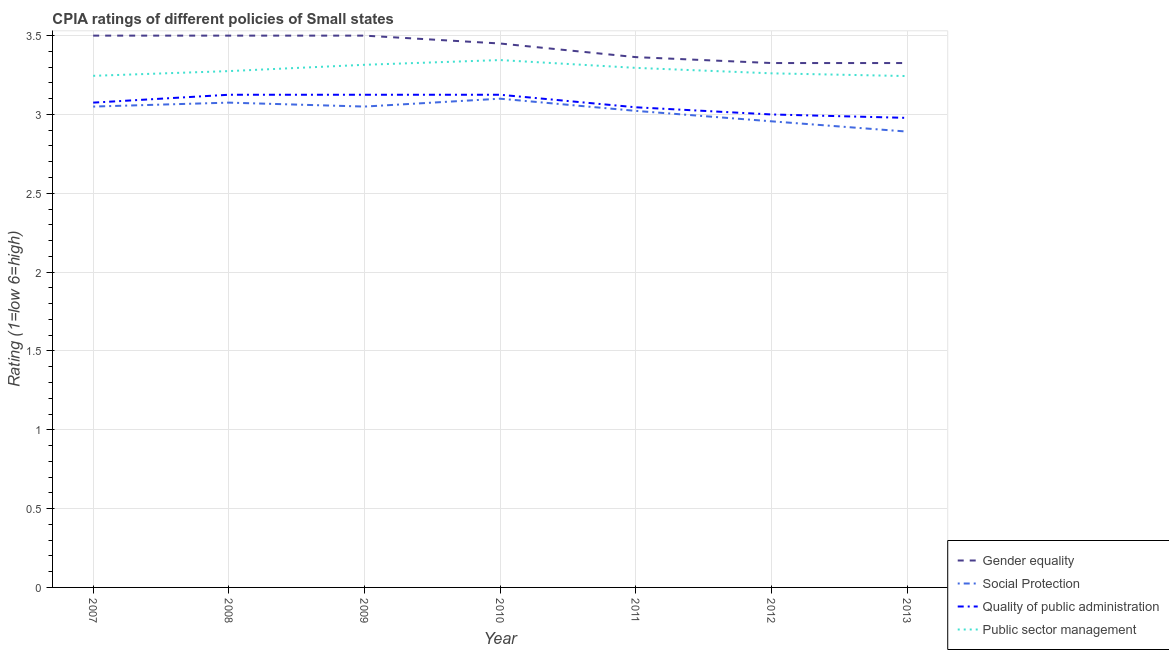What is the cpia rating of gender equality in 2013?
Your answer should be very brief. 3.33. Across all years, what is the maximum cpia rating of public sector management?
Keep it short and to the point. 3.35. Across all years, what is the minimum cpia rating of public sector management?
Your answer should be very brief. 3.24. In which year was the cpia rating of quality of public administration maximum?
Give a very brief answer. 2008. In which year was the cpia rating of gender equality minimum?
Offer a very short reply. 2012. What is the total cpia rating of public sector management in the graph?
Your answer should be very brief. 22.98. What is the difference between the cpia rating of gender equality in 2007 and that in 2010?
Make the answer very short. 0.05. What is the difference between the cpia rating of gender equality in 2009 and the cpia rating of social protection in 2012?
Offer a terse response. 0.54. What is the average cpia rating of social protection per year?
Ensure brevity in your answer.  3.02. In the year 2013, what is the difference between the cpia rating of gender equality and cpia rating of public sector management?
Offer a terse response. 0.08. Is the cpia rating of public sector management in 2007 less than that in 2009?
Your answer should be very brief. Yes. What is the difference between the highest and the second highest cpia rating of social protection?
Your response must be concise. 0.02. What is the difference between the highest and the lowest cpia rating of public sector management?
Make the answer very short. 0.1. Is it the case that in every year, the sum of the cpia rating of gender equality and cpia rating of social protection is greater than the cpia rating of quality of public administration?
Keep it short and to the point. Yes. Is the cpia rating of quality of public administration strictly less than the cpia rating of social protection over the years?
Give a very brief answer. No. What is the difference between two consecutive major ticks on the Y-axis?
Make the answer very short. 0.5. Are the values on the major ticks of Y-axis written in scientific E-notation?
Ensure brevity in your answer.  No. Does the graph contain any zero values?
Keep it short and to the point. No. Where does the legend appear in the graph?
Offer a very short reply. Bottom right. How many legend labels are there?
Your answer should be very brief. 4. What is the title of the graph?
Your answer should be very brief. CPIA ratings of different policies of Small states. What is the Rating (1=low 6=high) of Gender equality in 2007?
Give a very brief answer. 3.5. What is the Rating (1=low 6=high) in Social Protection in 2007?
Offer a terse response. 3.05. What is the Rating (1=low 6=high) of Quality of public administration in 2007?
Your response must be concise. 3.08. What is the Rating (1=low 6=high) of Public sector management in 2007?
Make the answer very short. 3.25. What is the Rating (1=low 6=high) of Social Protection in 2008?
Ensure brevity in your answer.  3.08. What is the Rating (1=low 6=high) of Quality of public administration in 2008?
Your answer should be very brief. 3.12. What is the Rating (1=low 6=high) of Public sector management in 2008?
Offer a very short reply. 3.27. What is the Rating (1=low 6=high) in Social Protection in 2009?
Ensure brevity in your answer.  3.05. What is the Rating (1=low 6=high) of Quality of public administration in 2009?
Offer a very short reply. 3.12. What is the Rating (1=low 6=high) of Public sector management in 2009?
Your response must be concise. 3.31. What is the Rating (1=low 6=high) in Gender equality in 2010?
Keep it short and to the point. 3.45. What is the Rating (1=low 6=high) of Quality of public administration in 2010?
Your answer should be very brief. 3.12. What is the Rating (1=low 6=high) in Public sector management in 2010?
Offer a terse response. 3.35. What is the Rating (1=low 6=high) of Gender equality in 2011?
Ensure brevity in your answer.  3.36. What is the Rating (1=low 6=high) in Social Protection in 2011?
Your answer should be compact. 3.02. What is the Rating (1=low 6=high) in Quality of public administration in 2011?
Give a very brief answer. 3.05. What is the Rating (1=low 6=high) in Public sector management in 2011?
Ensure brevity in your answer.  3.3. What is the Rating (1=low 6=high) in Gender equality in 2012?
Your answer should be compact. 3.33. What is the Rating (1=low 6=high) in Social Protection in 2012?
Your answer should be very brief. 2.96. What is the Rating (1=low 6=high) of Quality of public administration in 2012?
Your response must be concise. 3. What is the Rating (1=low 6=high) in Public sector management in 2012?
Provide a short and direct response. 3.26. What is the Rating (1=low 6=high) in Gender equality in 2013?
Provide a succinct answer. 3.33. What is the Rating (1=low 6=high) in Social Protection in 2013?
Keep it short and to the point. 2.89. What is the Rating (1=low 6=high) in Quality of public administration in 2013?
Keep it short and to the point. 2.98. What is the Rating (1=low 6=high) of Public sector management in 2013?
Offer a terse response. 3.24. Across all years, what is the maximum Rating (1=low 6=high) of Gender equality?
Your answer should be very brief. 3.5. Across all years, what is the maximum Rating (1=low 6=high) of Quality of public administration?
Keep it short and to the point. 3.12. Across all years, what is the maximum Rating (1=low 6=high) in Public sector management?
Keep it short and to the point. 3.35. Across all years, what is the minimum Rating (1=low 6=high) in Gender equality?
Ensure brevity in your answer.  3.33. Across all years, what is the minimum Rating (1=low 6=high) in Social Protection?
Provide a short and direct response. 2.89. Across all years, what is the minimum Rating (1=low 6=high) in Quality of public administration?
Keep it short and to the point. 2.98. Across all years, what is the minimum Rating (1=low 6=high) of Public sector management?
Your answer should be compact. 3.24. What is the total Rating (1=low 6=high) in Gender equality in the graph?
Your answer should be compact. 23.97. What is the total Rating (1=low 6=high) in Social Protection in the graph?
Make the answer very short. 21.15. What is the total Rating (1=low 6=high) in Quality of public administration in the graph?
Your response must be concise. 21.47. What is the total Rating (1=low 6=high) of Public sector management in the graph?
Provide a short and direct response. 22.98. What is the difference between the Rating (1=low 6=high) in Social Protection in 2007 and that in 2008?
Provide a succinct answer. -0.03. What is the difference between the Rating (1=low 6=high) in Public sector management in 2007 and that in 2008?
Make the answer very short. -0.03. What is the difference between the Rating (1=low 6=high) in Gender equality in 2007 and that in 2009?
Offer a terse response. 0. What is the difference between the Rating (1=low 6=high) in Quality of public administration in 2007 and that in 2009?
Provide a short and direct response. -0.05. What is the difference between the Rating (1=low 6=high) in Public sector management in 2007 and that in 2009?
Make the answer very short. -0.07. What is the difference between the Rating (1=low 6=high) in Social Protection in 2007 and that in 2010?
Ensure brevity in your answer.  -0.05. What is the difference between the Rating (1=low 6=high) of Public sector management in 2007 and that in 2010?
Provide a short and direct response. -0.1. What is the difference between the Rating (1=low 6=high) of Gender equality in 2007 and that in 2011?
Keep it short and to the point. 0.14. What is the difference between the Rating (1=low 6=high) in Social Protection in 2007 and that in 2011?
Offer a terse response. 0.03. What is the difference between the Rating (1=low 6=high) in Quality of public administration in 2007 and that in 2011?
Keep it short and to the point. 0.03. What is the difference between the Rating (1=low 6=high) of Public sector management in 2007 and that in 2011?
Offer a terse response. -0.05. What is the difference between the Rating (1=low 6=high) in Gender equality in 2007 and that in 2012?
Your response must be concise. 0.17. What is the difference between the Rating (1=low 6=high) of Social Protection in 2007 and that in 2012?
Keep it short and to the point. 0.09. What is the difference between the Rating (1=low 6=high) in Quality of public administration in 2007 and that in 2012?
Offer a very short reply. 0.07. What is the difference between the Rating (1=low 6=high) of Public sector management in 2007 and that in 2012?
Make the answer very short. -0.02. What is the difference between the Rating (1=low 6=high) in Gender equality in 2007 and that in 2013?
Your answer should be very brief. 0.17. What is the difference between the Rating (1=low 6=high) of Social Protection in 2007 and that in 2013?
Keep it short and to the point. 0.16. What is the difference between the Rating (1=low 6=high) of Quality of public administration in 2007 and that in 2013?
Your answer should be compact. 0.1. What is the difference between the Rating (1=low 6=high) in Public sector management in 2007 and that in 2013?
Make the answer very short. 0. What is the difference between the Rating (1=low 6=high) of Social Protection in 2008 and that in 2009?
Make the answer very short. 0.03. What is the difference between the Rating (1=low 6=high) in Public sector management in 2008 and that in 2009?
Ensure brevity in your answer.  -0.04. What is the difference between the Rating (1=low 6=high) in Gender equality in 2008 and that in 2010?
Offer a terse response. 0.05. What is the difference between the Rating (1=low 6=high) of Social Protection in 2008 and that in 2010?
Offer a terse response. -0.03. What is the difference between the Rating (1=low 6=high) in Quality of public administration in 2008 and that in 2010?
Your answer should be compact. 0. What is the difference between the Rating (1=low 6=high) of Public sector management in 2008 and that in 2010?
Offer a very short reply. -0.07. What is the difference between the Rating (1=low 6=high) in Gender equality in 2008 and that in 2011?
Your answer should be very brief. 0.14. What is the difference between the Rating (1=low 6=high) in Social Protection in 2008 and that in 2011?
Offer a very short reply. 0.05. What is the difference between the Rating (1=low 6=high) in Quality of public administration in 2008 and that in 2011?
Provide a short and direct response. 0.08. What is the difference between the Rating (1=low 6=high) in Public sector management in 2008 and that in 2011?
Keep it short and to the point. -0.02. What is the difference between the Rating (1=low 6=high) of Gender equality in 2008 and that in 2012?
Your answer should be compact. 0.17. What is the difference between the Rating (1=low 6=high) in Social Protection in 2008 and that in 2012?
Your answer should be very brief. 0.12. What is the difference between the Rating (1=low 6=high) in Quality of public administration in 2008 and that in 2012?
Your answer should be compact. 0.12. What is the difference between the Rating (1=low 6=high) in Public sector management in 2008 and that in 2012?
Provide a succinct answer. 0.01. What is the difference between the Rating (1=low 6=high) of Gender equality in 2008 and that in 2013?
Provide a short and direct response. 0.17. What is the difference between the Rating (1=low 6=high) of Social Protection in 2008 and that in 2013?
Ensure brevity in your answer.  0.18. What is the difference between the Rating (1=low 6=high) in Quality of public administration in 2008 and that in 2013?
Your answer should be very brief. 0.15. What is the difference between the Rating (1=low 6=high) in Public sector management in 2008 and that in 2013?
Your response must be concise. 0.03. What is the difference between the Rating (1=low 6=high) of Gender equality in 2009 and that in 2010?
Keep it short and to the point. 0.05. What is the difference between the Rating (1=low 6=high) in Social Protection in 2009 and that in 2010?
Provide a succinct answer. -0.05. What is the difference between the Rating (1=low 6=high) of Quality of public administration in 2009 and that in 2010?
Offer a terse response. 0. What is the difference between the Rating (1=low 6=high) of Public sector management in 2009 and that in 2010?
Make the answer very short. -0.03. What is the difference between the Rating (1=low 6=high) of Gender equality in 2009 and that in 2011?
Give a very brief answer. 0.14. What is the difference between the Rating (1=low 6=high) of Social Protection in 2009 and that in 2011?
Give a very brief answer. 0.03. What is the difference between the Rating (1=low 6=high) of Quality of public administration in 2009 and that in 2011?
Your answer should be compact. 0.08. What is the difference between the Rating (1=low 6=high) of Public sector management in 2009 and that in 2011?
Your answer should be compact. 0.02. What is the difference between the Rating (1=low 6=high) of Gender equality in 2009 and that in 2012?
Ensure brevity in your answer.  0.17. What is the difference between the Rating (1=low 6=high) in Social Protection in 2009 and that in 2012?
Offer a terse response. 0.09. What is the difference between the Rating (1=low 6=high) in Public sector management in 2009 and that in 2012?
Your response must be concise. 0.05. What is the difference between the Rating (1=low 6=high) in Gender equality in 2009 and that in 2013?
Give a very brief answer. 0.17. What is the difference between the Rating (1=low 6=high) in Social Protection in 2009 and that in 2013?
Give a very brief answer. 0.16. What is the difference between the Rating (1=low 6=high) of Quality of public administration in 2009 and that in 2013?
Ensure brevity in your answer.  0.15. What is the difference between the Rating (1=low 6=high) in Public sector management in 2009 and that in 2013?
Give a very brief answer. 0.07. What is the difference between the Rating (1=low 6=high) in Gender equality in 2010 and that in 2011?
Make the answer very short. 0.09. What is the difference between the Rating (1=low 6=high) in Social Protection in 2010 and that in 2011?
Make the answer very short. 0.08. What is the difference between the Rating (1=low 6=high) in Quality of public administration in 2010 and that in 2011?
Offer a very short reply. 0.08. What is the difference between the Rating (1=low 6=high) of Public sector management in 2010 and that in 2011?
Make the answer very short. 0.05. What is the difference between the Rating (1=low 6=high) in Gender equality in 2010 and that in 2012?
Your answer should be very brief. 0.12. What is the difference between the Rating (1=low 6=high) in Social Protection in 2010 and that in 2012?
Make the answer very short. 0.14. What is the difference between the Rating (1=low 6=high) in Public sector management in 2010 and that in 2012?
Your answer should be very brief. 0.08. What is the difference between the Rating (1=low 6=high) in Gender equality in 2010 and that in 2013?
Your answer should be compact. 0.12. What is the difference between the Rating (1=low 6=high) in Social Protection in 2010 and that in 2013?
Offer a terse response. 0.21. What is the difference between the Rating (1=low 6=high) of Quality of public administration in 2010 and that in 2013?
Ensure brevity in your answer.  0.15. What is the difference between the Rating (1=low 6=high) of Public sector management in 2010 and that in 2013?
Provide a succinct answer. 0.1. What is the difference between the Rating (1=low 6=high) of Gender equality in 2011 and that in 2012?
Provide a short and direct response. 0.04. What is the difference between the Rating (1=low 6=high) of Social Protection in 2011 and that in 2012?
Offer a very short reply. 0.07. What is the difference between the Rating (1=low 6=high) in Quality of public administration in 2011 and that in 2012?
Your answer should be very brief. 0.05. What is the difference between the Rating (1=low 6=high) of Public sector management in 2011 and that in 2012?
Your answer should be compact. 0.03. What is the difference between the Rating (1=low 6=high) of Gender equality in 2011 and that in 2013?
Provide a succinct answer. 0.04. What is the difference between the Rating (1=low 6=high) of Social Protection in 2011 and that in 2013?
Provide a succinct answer. 0.13. What is the difference between the Rating (1=low 6=high) of Quality of public administration in 2011 and that in 2013?
Give a very brief answer. 0.07. What is the difference between the Rating (1=low 6=high) in Public sector management in 2011 and that in 2013?
Your answer should be very brief. 0.05. What is the difference between the Rating (1=low 6=high) in Gender equality in 2012 and that in 2013?
Keep it short and to the point. 0. What is the difference between the Rating (1=low 6=high) in Social Protection in 2012 and that in 2013?
Offer a very short reply. 0.07. What is the difference between the Rating (1=low 6=high) in Quality of public administration in 2012 and that in 2013?
Offer a very short reply. 0.02. What is the difference between the Rating (1=low 6=high) of Public sector management in 2012 and that in 2013?
Provide a succinct answer. 0.02. What is the difference between the Rating (1=low 6=high) of Gender equality in 2007 and the Rating (1=low 6=high) of Social Protection in 2008?
Ensure brevity in your answer.  0.42. What is the difference between the Rating (1=low 6=high) of Gender equality in 2007 and the Rating (1=low 6=high) of Quality of public administration in 2008?
Make the answer very short. 0.38. What is the difference between the Rating (1=low 6=high) of Gender equality in 2007 and the Rating (1=low 6=high) of Public sector management in 2008?
Your answer should be compact. 0.23. What is the difference between the Rating (1=low 6=high) of Social Protection in 2007 and the Rating (1=low 6=high) of Quality of public administration in 2008?
Offer a very short reply. -0.07. What is the difference between the Rating (1=low 6=high) in Social Protection in 2007 and the Rating (1=low 6=high) in Public sector management in 2008?
Provide a short and direct response. -0.23. What is the difference between the Rating (1=low 6=high) in Quality of public administration in 2007 and the Rating (1=low 6=high) in Public sector management in 2008?
Ensure brevity in your answer.  -0.2. What is the difference between the Rating (1=low 6=high) of Gender equality in 2007 and the Rating (1=low 6=high) of Social Protection in 2009?
Keep it short and to the point. 0.45. What is the difference between the Rating (1=low 6=high) in Gender equality in 2007 and the Rating (1=low 6=high) in Public sector management in 2009?
Offer a terse response. 0.18. What is the difference between the Rating (1=low 6=high) of Social Protection in 2007 and the Rating (1=low 6=high) of Quality of public administration in 2009?
Provide a succinct answer. -0.07. What is the difference between the Rating (1=low 6=high) of Social Protection in 2007 and the Rating (1=low 6=high) of Public sector management in 2009?
Your response must be concise. -0.27. What is the difference between the Rating (1=low 6=high) in Quality of public administration in 2007 and the Rating (1=low 6=high) in Public sector management in 2009?
Your response must be concise. -0.24. What is the difference between the Rating (1=low 6=high) in Gender equality in 2007 and the Rating (1=low 6=high) in Social Protection in 2010?
Ensure brevity in your answer.  0.4. What is the difference between the Rating (1=low 6=high) in Gender equality in 2007 and the Rating (1=low 6=high) in Public sector management in 2010?
Keep it short and to the point. 0.15. What is the difference between the Rating (1=low 6=high) in Social Protection in 2007 and the Rating (1=low 6=high) in Quality of public administration in 2010?
Your response must be concise. -0.07. What is the difference between the Rating (1=low 6=high) of Social Protection in 2007 and the Rating (1=low 6=high) of Public sector management in 2010?
Provide a succinct answer. -0.29. What is the difference between the Rating (1=low 6=high) in Quality of public administration in 2007 and the Rating (1=low 6=high) in Public sector management in 2010?
Provide a short and direct response. -0.27. What is the difference between the Rating (1=low 6=high) in Gender equality in 2007 and the Rating (1=low 6=high) in Social Protection in 2011?
Provide a succinct answer. 0.48. What is the difference between the Rating (1=low 6=high) in Gender equality in 2007 and the Rating (1=low 6=high) in Quality of public administration in 2011?
Provide a succinct answer. 0.45. What is the difference between the Rating (1=low 6=high) in Gender equality in 2007 and the Rating (1=low 6=high) in Public sector management in 2011?
Give a very brief answer. 0.2. What is the difference between the Rating (1=low 6=high) of Social Protection in 2007 and the Rating (1=low 6=high) of Quality of public administration in 2011?
Your answer should be very brief. 0. What is the difference between the Rating (1=low 6=high) of Social Protection in 2007 and the Rating (1=low 6=high) of Public sector management in 2011?
Provide a succinct answer. -0.25. What is the difference between the Rating (1=low 6=high) of Quality of public administration in 2007 and the Rating (1=low 6=high) of Public sector management in 2011?
Offer a very short reply. -0.22. What is the difference between the Rating (1=low 6=high) in Gender equality in 2007 and the Rating (1=low 6=high) in Social Protection in 2012?
Offer a terse response. 0.54. What is the difference between the Rating (1=low 6=high) of Gender equality in 2007 and the Rating (1=low 6=high) of Public sector management in 2012?
Give a very brief answer. 0.24. What is the difference between the Rating (1=low 6=high) of Social Protection in 2007 and the Rating (1=low 6=high) of Quality of public administration in 2012?
Make the answer very short. 0.05. What is the difference between the Rating (1=low 6=high) of Social Protection in 2007 and the Rating (1=low 6=high) of Public sector management in 2012?
Your answer should be very brief. -0.21. What is the difference between the Rating (1=low 6=high) in Quality of public administration in 2007 and the Rating (1=low 6=high) in Public sector management in 2012?
Your response must be concise. -0.19. What is the difference between the Rating (1=low 6=high) of Gender equality in 2007 and the Rating (1=low 6=high) of Social Protection in 2013?
Your answer should be compact. 0.61. What is the difference between the Rating (1=low 6=high) of Gender equality in 2007 and the Rating (1=low 6=high) of Quality of public administration in 2013?
Offer a terse response. 0.52. What is the difference between the Rating (1=low 6=high) of Gender equality in 2007 and the Rating (1=low 6=high) of Public sector management in 2013?
Your response must be concise. 0.26. What is the difference between the Rating (1=low 6=high) in Social Protection in 2007 and the Rating (1=low 6=high) in Quality of public administration in 2013?
Your answer should be very brief. 0.07. What is the difference between the Rating (1=low 6=high) in Social Protection in 2007 and the Rating (1=low 6=high) in Public sector management in 2013?
Your response must be concise. -0.19. What is the difference between the Rating (1=low 6=high) of Quality of public administration in 2007 and the Rating (1=low 6=high) of Public sector management in 2013?
Make the answer very short. -0.17. What is the difference between the Rating (1=low 6=high) of Gender equality in 2008 and the Rating (1=low 6=high) of Social Protection in 2009?
Give a very brief answer. 0.45. What is the difference between the Rating (1=low 6=high) in Gender equality in 2008 and the Rating (1=low 6=high) in Public sector management in 2009?
Keep it short and to the point. 0.18. What is the difference between the Rating (1=low 6=high) in Social Protection in 2008 and the Rating (1=low 6=high) in Quality of public administration in 2009?
Make the answer very short. -0.05. What is the difference between the Rating (1=low 6=high) of Social Protection in 2008 and the Rating (1=low 6=high) of Public sector management in 2009?
Your answer should be compact. -0.24. What is the difference between the Rating (1=low 6=high) of Quality of public administration in 2008 and the Rating (1=low 6=high) of Public sector management in 2009?
Your response must be concise. -0.19. What is the difference between the Rating (1=low 6=high) in Gender equality in 2008 and the Rating (1=low 6=high) in Social Protection in 2010?
Your answer should be very brief. 0.4. What is the difference between the Rating (1=low 6=high) in Gender equality in 2008 and the Rating (1=low 6=high) in Public sector management in 2010?
Your answer should be compact. 0.15. What is the difference between the Rating (1=low 6=high) in Social Protection in 2008 and the Rating (1=low 6=high) in Quality of public administration in 2010?
Give a very brief answer. -0.05. What is the difference between the Rating (1=low 6=high) of Social Protection in 2008 and the Rating (1=low 6=high) of Public sector management in 2010?
Make the answer very short. -0.27. What is the difference between the Rating (1=low 6=high) of Quality of public administration in 2008 and the Rating (1=low 6=high) of Public sector management in 2010?
Keep it short and to the point. -0.22. What is the difference between the Rating (1=low 6=high) of Gender equality in 2008 and the Rating (1=low 6=high) of Social Protection in 2011?
Offer a terse response. 0.48. What is the difference between the Rating (1=low 6=high) in Gender equality in 2008 and the Rating (1=low 6=high) in Quality of public administration in 2011?
Provide a succinct answer. 0.45. What is the difference between the Rating (1=low 6=high) in Gender equality in 2008 and the Rating (1=low 6=high) in Public sector management in 2011?
Your answer should be compact. 0.2. What is the difference between the Rating (1=low 6=high) of Social Protection in 2008 and the Rating (1=low 6=high) of Quality of public administration in 2011?
Offer a terse response. 0.03. What is the difference between the Rating (1=low 6=high) of Social Protection in 2008 and the Rating (1=low 6=high) of Public sector management in 2011?
Give a very brief answer. -0.22. What is the difference between the Rating (1=low 6=high) of Quality of public administration in 2008 and the Rating (1=low 6=high) of Public sector management in 2011?
Offer a terse response. -0.17. What is the difference between the Rating (1=low 6=high) of Gender equality in 2008 and the Rating (1=low 6=high) of Social Protection in 2012?
Keep it short and to the point. 0.54. What is the difference between the Rating (1=low 6=high) in Gender equality in 2008 and the Rating (1=low 6=high) in Quality of public administration in 2012?
Offer a very short reply. 0.5. What is the difference between the Rating (1=low 6=high) of Gender equality in 2008 and the Rating (1=low 6=high) of Public sector management in 2012?
Your answer should be compact. 0.24. What is the difference between the Rating (1=low 6=high) in Social Protection in 2008 and the Rating (1=low 6=high) in Quality of public administration in 2012?
Provide a short and direct response. 0.07. What is the difference between the Rating (1=low 6=high) of Social Protection in 2008 and the Rating (1=low 6=high) of Public sector management in 2012?
Your response must be concise. -0.19. What is the difference between the Rating (1=low 6=high) in Quality of public administration in 2008 and the Rating (1=low 6=high) in Public sector management in 2012?
Offer a terse response. -0.14. What is the difference between the Rating (1=low 6=high) in Gender equality in 2008 and the Rating (1=low 6=high) in Social Protection in 2013?
Your answer should be very brief. 0.61. What is the difference between the Rating (1=low 6=high) of Gender equality in 2008 and the Rating (1=low 6=high) of Quality of public administration in 2013?
Make the answer very short. 0.52. What is the difference between the Rating (1=low 6=high) of Gender equality in 2008 and the Rating (1=low 6=high) of Public sector management in 2013?
Your response must be concise. 0.26. What is the difference between the Rating (1=low 6=high) of Social Protection in 2008 and the Rating (1=low 6=high) of Quality of public administration in 2013?
Provide a succinct answer. 0.1. What is the difference between the Rating (1=low 6=high) in Social Protection in 2008 and the Rating (1=low 6=high) in Public sector management in 2013?
Make the answer very short. -0.17. What is the difference between the Rating (1=low 6=high) in Quality of public administration in 2008 and the Rating (1=low 6=high) in Public sector management in 2013?
Keep it short and to the point. -0.12. What is the difference between the Rating (1=low 6=high) of Gender equality in 2009 and the Rating (1=low 6=high) of Social Protection in 2010?
Your answer should be compact. 0.4. What is the difference between the Rating (1=low 6=high) of Gender equality in 2009 and the Rating (1=low 6=high) of Public sector management in 2010?
Your response must be concise. 0.15. What is the difference between the Rating (1=low 6=high) in Social Protection in 2009 and the Rating (1=low 6=high) in Quality of public administration in 2010?
Your response must be concise. -0.07. What is the difference between the Rating (1=low 6=high) of Social Protection in 2009 and the Rating (1=low 6=high) of Public sector management in 2010?
Ensure brevity in your answer.  -0.29. What is the difference between the Rating (1=low 6=high) of Quality of public administration in 2009 and the Rating (1=low 6=high) of Public sector management in 2010?
Keep it short and to the point. -0.22. What is the difference between the Rating (1=low 6=high) in Gender equality in 2009 and the Rating (1=low 6=high) in Social Protection in 2011?
Provide a succinct answer. 0.48. What is the difference between the Rating (1=low 6=high) of Gender equality in 2009 and the Rating (1=low 6=high) of Quality of public administration in 2011?
Offer a terse response. 0.45. What is the difference between the Rating (1=low 6=high) in Gender equality in 2009 and the Rating (1=low 6=high) in Public sector management in 2011?
Your response must be concise. 0.2. What is the difference between the Rating (1=low 6=high) in Social Protection in 2009 and the Rating (1=low 6=high) in Quality of public administration in 2011?
Give a very brief answer. 0. What is the difference between the Rating (1=low 6=high) in Social Protection in 2009 and the Rating (1=low 6=high) in Public sector management in 2011?
Offer a terse response. -0.25. What is the difference between the Rating (1=low 6=high) of Quality of public administration in 2009 and the Rating (1=low 6=high) of Public sector management in 2011?
Ensure brevity in your answer.  -0.17. What is the difference between the Rating (1=low 6=high) in Gender equality in 2009 and the Rating (1=low 6=high) in Social Protection in 2012?
Ensure brevity in your answer.  0.54. What is the difference between the Rating (1=low 6=high) of Gender equality in 2009 and the Rating (1=low 6=high) of Quality of public administration in 2012?
Provide a short and direct response. 0.5. What is the difference between the Rating (1=low 6=high) in Gender equality in 2009 and the Rating (1=low 6=high) in Public sector management in 2012?
Keep it short and to the point. 0.24. What is the difference between the Rating (1=low 6=high) in Social Protection in 2009 and the Rating (1=low 6=high) in Quality of public administration in 2012?
Your answer should be compact. 0.05. What is the difference between the Rating (1=low 6=high) in Social Protection in 2009 and the Rating (1=low 6=high) in Public sector management in 2012?
Your response must be concise. -0.21. What is the difference between the Rating (1=low 6=high) of Quality of public administration in 2009 and the Rating (1=low 6=high) of Public sector management in 2012?
Your answer should be very brief. -0.14. What is the difference between the Rating (1=low 6=high) in Gender equality in 2009 and the Rating (1=low 6=high) in Social Protection in 2013?
Your response must be concise. 0.61. What is the difference between the Rating (1=low 6=high) in Gender equality in 2009 and the Rating (1=low 6=high) in Quality of public administration in 2013?
Your answer should be very brief. 0.52. What is the difference between the Rating (1=low 6=high) in Gender equality in 2009 and the Rating (1=low 6=high) in Public sector management in 2013?
Give a very brief answer. 0.26. What is the difference between the Rating (1=low 6=high) in Social Protection in 2009 and the Rating (1=low 6=high) in Quality of public administration in 2013?
Provide a short and direct response. 0.07. What is the difference between the Rating (1=low 6=high) of Social Protection in 2009 and the Rating (1=low 6=high) of Public sector management in 2013?
Keep it short and to the point. -0.19. What is the difference between the Rating (1=low 6=high) of Quality of public administration in 2009 and the Rating (1=low 6=high) of Public sector management in 2013?
Your response must be concise. -0.12. What is the difference between the Rating (1=low 6=high) in Gender equality in 2010 and the Rating (1=low 6=high) in Social Protection in 2011?
Make the answer very short. 0.43. What is the difference between the Rating (1=low 6=high) in Gender equality in 2010 and the Rating (1=low 6=high) in Quality of public administration in 2011?
Provide a succinct answer. 0.4. What is the difference between the Rating (1=low 6=high) of Gender equality in 2010 and the Rating (1=low 6=high) of Public sector management in 2011?
Provide a short and direct response. 0.15. What is the difference between the Rating (1=low 6=high) of Social Protection in 2010 and the Rating (1=low 6=high) of Quality of public administration in 2011?
Offer a terse response. 0.05. What is the difference between the Rating (1=low 6=high) of Social Protection in 2010 and the Rating (1=low 6=high) of Public sector management in 2011?
Give a very brief answer. -0.2. What is the difference between the Rating (1=low 6=high) of Quality of public administration in 2010 and the Rating (1=low 6=high) of Public sector management in 2011?
Keep it short and to the point. -0.17. What is the difference between the Rating (1=low 6=high) of Gender equality in 2010 and the Rating (1=low 6=high) of Social Protection in 2012?
Offer a terse response. 0.49. What is the difference between the Rating (1=low 6=high) of Gender equality in 2010 and the Rating (1=low 6=high) of Quality of public administration in 2012?
Offer a terse response. 0.45. What is the difference between the Rating (1=low 6=high) in Gender equality in 2010 and the Rating (1=low 6=high) in Public sector management in 2012?
Your response must be concise. 0.19. What is the difference between the Rating (1=low 6=high) in Social Protection in 2010 and the Rating (1=low 6=high) in Quality of public administration in 2012?
Provide a succinct answer. 0.1. What is the difference between the Rating (1=low 6=high) in Social Protection in 2010 and the Rating (1=low 6=high) in Public sector management in 2012?
Your answer should be compact. -0.16. What is the difference between the Rating (1=low 6=high) of Quality of public administration in 2010 and the Rating (1=low 6=high) of Public sector management in 2012?
Make the answer very short. -0.14. What is the difference between the Rating (1=low 6=high) in Gender equality in 2010 and the Rating (1=low 6=high) in Social Protection in 2013?
Offer a very short reply. 0.56. What is the difference between the Rating (1=low 6=high) in Gender equality in 2010 and the Rating (1=low 6=high) in Quality of public administration in 2013?
Provide a succinct answer. 0.47. What is the difference between the Rating (1=low 6=high) in Gender equality in 2010 and the Rating (1=low 6=high) in Public sector management in 2013?
Offer a terse response. 0.21. What is the difference between the Rating (1=low 6=high) of Social Protection in 2010 and the Rating (1=low 6=high) of Quality of public administration in 2013?
Your response must be concise. 0.12. What is the difference between the Rating (1=low 6=high) in Social Protection in 2010 and the Rating (1=low 6=high) in Public sector management in 2013?
Offer a very short reply. -0.14. What is the difference between the Rating (1=low 6=high) in Quality of public administration in 2010 and the Rating (1=low 6=high) in Public sector management in 2013?
Offer a very short reply. -0.12. What is the difference between the Rating (1=low 6=high) of Gender equality in 2011 and the Rating (1=low 6=high) of Social Protection in 2012?
Make the answer very short. 0.41. What is the difference between the Rating (1=low 6=high) in Gender equality in 2011 and the Rating (1=low 6=high) in Quality of public administration in 2012?
Ensure brevity in your answer.  0.36. What is the difference between the Rating (1=low 6=high) of Gender equality in 2011 and the Rating (1=low 6=high) of Public sector management in 2012?
Offer a terse response. 0.1. What is the difference between the Rating (1=low 6=high) in Social Protection in 2011 and the Rating (1=low 6=high) in Quality of public administration in 2012?
Your answer should be compact. 0.02. What is the difference between the Rating (1=low 6=high) of Social Protection in 2011 and the Rating (1=low 6=high) of Public sector management in 2012?
Offer a very short reply. -0.24. What is the difference between the Rating (1=low 6=high) of Quality of public administration in 2011 and the Rating (1=low 6=high) of Public sector management in 2012?
Your response must be concise. -0.22. What is the difference between the Rating (1=low 6=high) of Gender equality in 2011 and the Rating (1=low 6=high) of Social Protection in 2013?
Your answer should be compact. 0.47. What is the difference between the Rating (1=low 6=high) of Gender equality in 2011 and the Rating (1=low 6=high) of Quality of public administration in 2013?
Provide a short and direct response. 0.39. What is the difference between the Rating (1=low 6=high) in Gender equality in 2011 and the Rating (1=low 6=high) in Public sector management in 2013?
Provide a succinct answer. 0.12. What is the difference between the Rating (1=low 6=high) of Social Protection in 2011 and the Rating (1=low 6=high) of Quality of public administration in 2013?
Your response must be concise. 0.04. What is the difference between the Rating (1=low 6=high) in Social Protection in 2011 and the Rating (1=low 6=high) in Public sector management in 2013?
Your response must be concise. -0.22. What is the difference between the Rating (1=low 6=high) in Quality of public administration in 2011 and the Rating (1=low 6=high) in Public sector management in 2013?
Your answer should be very brief. -0.2. What is the difference between the Rating (1=low 6=high) of Gender equality in 2012 and the Rating (1=low 6=high) of Social Protection in 2013?
Provide a short and direct response. 0.43. What is the difference between the Rating (1=low 6=high) in Gender equality in 2012 and the Rating (1=low 6=high) in Quality of public administration in 2013?
Keep it short and to the point. 0.35. What is the difference between the Rating (1=low 6=high) in Gender equality in 2012 and the Rating (1=low 6=high) in Public sector management in 2013?
Ensure brevity in your answer.  0.08. What is the difference between the Rating (1=low 6=high) in Social Protection in 2012 and the Rating (1=low 6=high) in Quality of public administration in 2013?
Your response must be concise. -0.02. What is the difference between the Rating (1=low 6=high) in Social Protection in 2012 and the Rating (1=low 6=high) in Public sector management in 2013?
Keep it short and to the point. -0.29. What is the difference between the Rating (1=low 6=high) of Quality of public administration in 2012 and the Rating (1=low 6=high) of Public sector management in 2013?
Your answer should be compact. -0.24. What is the average Rating (1=low 6=high) in Gender equality per year?
Offer a very short reply. 3.42. What is the average Rating (1=low 6=high) in Social Protection per year?
Ensure brevity in your answer.  3.02. What is the average Rating (1=low 6=high) in Quality of public administration per year?
Offer a very short reply. 3.07. What is the average Rating (1=low 6=high) in Public sector management per year?
Make the answer very short. 3.28. In the year 2007, what is the difference between the Rating (1=low 6=high) in Gender equality and Rating (1=low 6=high) in Social Protection?
Your response must be concise. 0.45. In the year 2007, what is the difference between the Rating (1=low 6=high) of Gender equality and Rating (1=low 6=high) of Quality of public administration?
Your answer should be compact. 0.42. In the year 2007, what is the difference between the Rating (1=low 6=high) of Gender equality and Rating (1=low 6=high) of Public sector management?
Offer a terse response. 0.26. In the year 2007, what is the difference between the Rating (1=low 6=high) of Social Protection and Rating (1=low 6=high) of Quality of public administration?
Provide a succinct answer. -0.03. In the year 2007, what is the difference between the Rating (1=low 6=high) in Social Protection and Rating (1=low 6=high) in Public sector management?
Your response must be concise. -0.2. In the year 2007, what is the difference between the Rating (1=low 6=high) in Quality of public administration and Rating (1=low 6=high) in Public sector management?
Your response must be concise. -0.17. In the year 2008, what is the difference between the Rating (1=low 6=high) of Gender equality and Rating (1=low 6=high) of Social Protection?
Your answer should be very brief. 0.42. In the year 2008, what is the difference between the Rating (1=low 6=high) of Gender equality and Rating (1=low 6=high) of Public sector management?
Your answer should be compact. 0.23. In the year 2009, what is the difference between the Rating (1=low 6=high) of Gender equality and Rating (1=low 6=high) of Social Protection?
Offer a very short reply. 0.45. In the year 2009, what is the difference between the Rating (1=low 6=high) of Gender equality and Rating (1=low 6=high) of Quality of public administration?
Provide a short and direct response. 0.38. In the year 2009, what is the difference between the Rating (1=low 6=high) of Gender equality and Rating (1=low 6=high) of Public sector management?
Offer a terse response. 0.18. In the year 2009, what is the difference between the Rating (1=low 6=high) in Social Protection and Rating (1=low 6=high) in Quality of public administration?
Offer a very short reply. -0.07. In the year 2009, what is the difference between the Rating (1=low 6=high) in Social Protection and Rating (1=low 6=high) in Public sector management?
Provide a succinct answer. -0.27. In the year 2009, what is the difference between the Rating (1=low 6=high) in Quality of public administration and Rating (1=low 6=high) in Public sector management?
Offer a very short reply. -0.19. In the year 2010, what is the difference between the Rating (1=low 6=high) in Gender equality and Rating (1=low 6=high) in Social Protection?
Give a very brief answer. 0.35. In the year 2010, what is the difference between the Rating (1=low 6=high) in Gender equality and Rating (1=low 6=high) in Quality of public administration?
Ensure brevity in your answer.  0.33. In the year 2010, what is the difference between the Rating (1=low 6=high) in Gender equality and Rating (1=low 6=high) in Public sector management?
Make the answer very short. 0.1. In the year 2010, what is the difference between the Rating (1=low 6=high) in Social Protection and Rating (1=low 6=high) in Quality of public administration?
Keep it short and to the point. -0.03. In the year 2010, what is the difference between the Rating (1=low 6=high) of Social Protection and Rating (1=low 6=high) of Public sector management?
Offer a terse response. -0.24. In the year 2010, what is the difference between the Rating (1=low 6=high) in Quality of public administration and Rating (1=low 6=high) in Public sector management?
Your response must be concise. -0.22. In the year 2011, what is the difference between the Rating (1=low 6=high) in Gender equality and Rating (1=low 6=high) in Social Protection?
Provide a succinct answer. 0.34. In the year 2011, what is the difference between the Rating (1=low 6=high) of Gender equality and Rating (1=low 6=high) of Quality of public administration?
Keep it short and to the point. 0.32. In the year 2011, what is the difference between the Rating (1=low 6=high) in Gender equality and Rating (1=low 6=high) in Public sector management?
Your answer should be very brief. 0.07. In the year 2011, what is the difference between the Rating (1=low 6=high) in Social Protection and Rating (1=low 6=high) in Quality of public administration?
Give a very brief answer. -0.02. In the year 2011, what is the difference between the Rating (1=low 6=high) of Social Protection and Rating (1=low 6=high) of Public sector management?
Your response must be concise. -0.27. In the year 2011, what is the difference between the Rating (1=low 6=high) of Quality of public administration and Rating (1=low 6=high) of Public sector management?
Offer a very short reply. -0.25. In the year 2012, what is the difference between the Rating (1=low 6=high) of Gender equality and Rating (1=low 6=high) of Social Protection?
Provide a short and direct response. 0.37. In the year 2012, what is the difference between the Rating (1=low 6=high) in Gender equality and Rating (1=low 6=high) in Quality of public administration?
Provide a short and direct response. 0.33. In the year 2012, what is the difference between the Rating (1=low 6=high) of Gender equality and Rating (1=low 6=high) of Public sector management?
Your response must be concise. 0.07. In the year 2012, what is the difference between the Rating (1=low 6=high) in Social Protection and Rating (1=low 6=high) in Quality of public administration?
Offer a terse response. -0.04. In the year 2012, what is the difference between the Rating (1=low 6=high) in Social Protection and Rating (1=low 6=high) in Public sector management?
Keep it short and to the point. -0.3. In the year 2012, what is the difference between the Rating (1=low 6=high) of Quality of public administration and Rating (1=low 6=high) of Public sector management?
Give a very brief answer. -0.26. In the year 2013, what is the difference between the Rating (1=low 6=high) of Gender equality and Rating (1=low 6=high) of Social Protection?
Your answer should be very brief. 0.43. In the year 2013, what is the difference between the Rating (1=low 6=high) of Gender equality and Rating (1=low 6=high) of Quality of public administration?
Provide a succinct answer. 0.35. In the year 2013, what is the difference between the Rating (1=low 6=high) in Gender equality and Rating (1=low 6=high) in Public sector management?
Provide a short and direct response. 0.08. In the year 2013, what is the difference between the Rating (1=low 6=high) in Social Protection and Rating (1=low 6=high) in Quality of public administration?
Provide a short and direct response. -0.09. In the year 2013, what is the difference between the Rating (1=low 6=high) of Social Protection and Rating (1=low 6=high) of Public sector management?
Your answer should be very brief. -0.35. In the year 2013, what is the difference between the Rating (1=low 6=high) of Quality of public administration and Rating (1=low 6=high) of Public sector management?
Your answer should be compact. -0.27. What is the ratio of the Rating (1=low 6=high) in Social Protection in 2007 to that in 2008?
Provide a short and direct response. 0.99. What is the ratio of the Rating (1=low 6=high) of Quality of public administration in 2007 to that in 2008?
Provide a succinct answer. 0.98. What is the ratio of the Rating (1=low 6=high) of Social Protection in 2007 to that in 2009?
Give a very brief answer. 1. What is the ratio of the Rating (1=low 6=high) of Quality of public administration in 2007 to that in 2009?
Keep it short and to the point. 0.98. What is the ratio of the Rating (1=low 6=high) of Public sector management in 2007 to that in 2009?
Offer a very short reply. 0.98. What is the ratio of the Rating (1=low 6=high) in Gender equality in 2007 to that in 2010?
Your response must be concise. 1.01. What is the ratio of the Rating (1=low 6=high) of Social Protection in 2007 to that in 2010?
Provide a succinct answer. 0.98. What is the ratio of the Rating (1=low 6=high) of Quality of public administration in 2007 to that in 2010?
Offer a terse response. 0.98. What is the ratio of the Rating (1=low 6=high) of Public sector management in 2007 to that in 2010?
Give a very brief answer. 0.97. What is the ratio of the Rating (1=low 6=high) of Gender equality in 2007 to that in 2011?
Make the answer very short. 1.04. What is the ratio of the Rating (1=low 6=high) in Social Protection in 2007 to that in 2011?
Offer a terse response. 1.01. What is the ratio of the Rating (1=low 6=high) in Quality of public administration in 2007 to that in 2011?
Provide a succinct answer. 1.01. What is the ratio of the Rating (1=low 6=high) in Public sector management in 2007 to that in 2011?
Make the answer very short. 0.98. What is the ratio of the Rating (1=low 6=high) in Gender equality in 2007 to that in 2012?
Provide a succinct answer. 1.05. What is the ratio of the Rating (1=low 6=high) in Social Protection in 2007 to that in 2012?
Your answer should be compact. 1.03. What is the ratio of the Rating (1=low 6=high) of Quality of public administration in 2007 to that in 2012?
Offer a very short reply. 1.02. What is the ratio of the Rating (1=low 6=high) in Public sector management in 2007 to that in 2012?
Provide a short and direct response. 1. What is the ratio of the Rating (1=low 6=high) in Gender equality in 2007 to that in 2013?
Your answer should be compact. 1.05. What is the ratio of the Rating (1=low 6=high) of Social Protection in 2007 to that in 2013?
Provide a short and direct response. 1.05. What is the ratio of the Rating (1=low 6=high) of Quality of public administration in 2007 to that in 2013?
Ensure brevity in your answer.  1.03. What is the ratio of the Rating (1=low 6=high) of Public sector management in 2007 to that in 2013?
Ensure brevity in your answer.  1. What is the ratio of the Rating (1=low 6=high) in Gender equality in 2008 to that in 2009?
Keep it short and to the point. 1. What is the ratio of the Rating (1=low 6=high) in Social Protection in 2008 to that in 2009?
Keep it short and to the point. 1.01. What is the ratio of the Rating (1=low 6=high) in Quality of public administration in 2008 to that in 2009?
Your answer should be very brief. 1. What is the ratio of the Rating (1=low 6=high) in Public sector management in 2008 to that in 2009?
Give a very brief answer. 0.99. What is the ratio of the Rating (1=low 6=high) in Gender equality in 2008 to that in 2010?
Your response must be concise. 1.01. What is the ratio of the Rating (1=low 6=high) of Social Protection in 2008 to that in 2010?
Your answer should be very brief. 0.99. What is the ratio of the Rating (1=low 6=high) of Public sector management in 2008 to that in 2010?
Keep it short and to the point. 0.98. What is the ratio of the Rating (1=low 6=high) in Gender equality in 2008 to that in 2011?
Your answer should be very brief. 1.04. What is the ratio of the Rating (1=low 6=high) of Social Protection in 2008 to that in 2011?
Make the answer very short. 1.02. What is the ratio of the Rating (1=low 6=high) in Quality of public administration in 2008 to that in 2011?
Give a very brief answer. 1.03. What is the ratio of the Rating (1=low 6=high) of Gender equality in 2008 to that in 2012?
Provide a succinct answer. 1.05. What is the ratio of the Rating (1=low 6=high) of Social Protection in 2008 to that in 2012?
Give a very brief answer. 1.04. What is the ratio of the Rating (1=low 6=high) in Quality of public administration in 2008 to that in 2012?
Your answer should be compact. 1.04. What is the ratio of the Rating (1=low 6=high) in Public sector management in 2008 to that in 2012?
Offer a terse response. 1. What is the ratio of the Rating (1=low 6=high) in Gender equality in 2008 to that in 2013?
Ensure brevity in your answer.  1.05. What is the ratio of the Rating (1=low 6=high) in Social Protection in 2008 to that in 2013?
Your answer should be compact. 1.06. What is the ratio of the Rating (1=low 6=high) of Quality of public administration in 2008 to that in 2013?
Your response must be concise. 1.05. What is the ratio of the Rating (1=low 6=high) of Public sector management in 2008 to that in 2013?
Ensure brevity in your answer.  1.01. What is the ratio of the Rating (1=low 6=high) of Gender equality in 2009 to that in 2010?
Keep it short and to the point. 1.01. What is the ratio of the Rating (1=low 6=high) of Social Protection in 2009 to that in 2010?
Ensure brevity in your answer.  0.98. What is the ratio of the Rating (1=low 6=high) of Gender equality in 2009 to that in 2011?
Provide a short and direct response. 1.04. What is the ratio of the Rating (1=low 6=high) of Social Protection in 2009 to that in 2011?
Offer a terse response. 1.01. What is the ratio of the Rating (1=low 6=high) in Quality of public administration in 2009 to that in 2011?
Your response must be concise. 1.03. What is the ratio of the Rating (1=low 6=high) of Public sector management in 2009 to that in 2011?
Give a very brief answer. 1.01. What is the ratio of the Rating (1=low 6=high) in Gender equality in 2009 to that in 2012?
Give a very brief answer. 1.05. What is the ratio of the Rating (1=low 6=high) of Social Protection in 2009 to that in 2012?
Offer a very short reply. 1.03. What is the ratio of the Rating (1=low 6=high) in Quality of public administration in 2009 to that in 2012?
Give a very brief answer. 1.04. What is the ratio of the Rating (1=low 6=high) in Public sector management in 2009 to that in 2012?
Provide a succinct answer. 1.02. What is the ratio of the Rating (1=low 6=high) of Gender equality in 2009 to that in 2013?
Your response must be concise. 1.05. What is the ratio of the Rating (1=low 6=high) in Social Protection in 2009 to that in 2013?
Ensure brevity in your answer.  1.05. What is the ratio of the Rating (1=low 6=high) of Quality of public administration in 2009 to that in 2013?
Ensure brevity in your answer.  1.05. What is the ratio of the Rating (1=low 6=high) in Public sector management in 2009 to that in 2013?
Your response must be concise. 1.02. What is the ratio of the Rating (1=low 6=high) in Gender equality in 2010 to that in 2011?
Your answer should be compact. 1.03. What is the ratio of the Rating (1=low 6=high) of Social Protection in 2010 to that in 2011?
Make the answer very short. 1.03. What is the ratio of the Rating (1=low 6=high) in Quality of public administration in 2010 to that in 2011?
Give a very brief answer. 1.03. What is the ratio of the Rating (1=low 6=high) of Public sector management in 2010 to that in 2011?
Provide a short and direct response. 1.01. What is the ratio of the Rating (1=low 6=high) in Gender equality in 2010 to that in 2012?
Give a very brief answer. 1.04. What is the ratio of the Rating (1=low 6=high) of Social Protection in 2010 to that in 2012?
Give a very brief answer. 1.05. What is the ratio of the Rating (1=low 6=high) in Quality of public administration in 2010 to that in 2012?
Your answer should be very brief. 1.04. What is the ratio of the Rating (1=low 6=high) in Public sector management in 2010 to that in 2012?
Provide a succinct answer. 1.03. What is the ratio of the Rating (1=low 6=high) in Gender equality in 2010 to that in 2013?
Your answer should be very brief. 1.04. What is the ratio of the Rating (1=low 6=high) of Social Protection in 2010 to that in 2013?
Provide a short and direct response. 1.07. What is the ratio of the Rating (1=low 6=high) of Quality of public administration in 2010 to that in 2013?
Ensure brevity in your answer.  1.05. What is the ratio of the Rating (1=low 6=high) in Public sector management in 2010 to that in 2013?
Ensure brevity in your answer.  1.03. What is the ratio of the Rating (1=low 6=high) of Gender equality in 2011 to that in 2012?
Offer a very short reply. 1.01. What is the ratio of the Rating (1=low 6=high) in Social Protection in 2011 to that in 2012?
Offer a very short reply. 1.02. What is the ratio of the Rating (1=low 6=high) of Quality of public administration in 2011 to that in 2012?
Provide a short and direct response. 1.02. What is the ratio of the Rating (1=low 6=high) of Public sector management in 2011 to that in 2012?
Offer a terse response. 1.01. What is the ratio of the Rating (1=low 6=high) of Gender equality in 2011 to that in 2013?
Give a very brief answer. 1.01. What is the ratio of the Rating (1=low 6=high) of Social Protection in 2011 to that in 2013?
Ensure brevity in your answer.  1.05. What is the ratio of the Rating (1=low 6=high) in Quality of public administration in 2011 to that in 2013?
Your answer should be very brief. 1.02. What is the ratio of the Rating (1=low 6=high) of Public sector management in 2011 to that in 2013?
Provide a short and direct response. 1.02. What is the ratio of the Rating (1=low 6=high) of Social Protection in 2012 to that in 2013?
Your answer should be compact. 1.02. What is the ratio of the Rating (1=low 6=high) of Quality of public administration in 2012 to that in 2013?
Your answer should be compact. 1.01. What is the ratio of the Rating (1=low 6=high) in Public sector management in 2012 to that in 2013?
Provide a short and direct response. 1.01. What is the difference between the highest and the second highest Rating (1=low 6=high) of Social Protection?
Provide a short and direct response. 0.03. What is the difference between the highest and the second highest Rating (1=low 6=high) in Quality of public administration?
Make the answer very short. 0. What is the difference between the highest and the second highest Rating (1=low 6=high) of Public sector management?
Give a very brief answer. 0.03. What is the difference between the highest and the lowest Rating (1=low 6=high) of Gender equality?
Your answer should be very brief. 0.17. What is the difference between the highest and the lowest Rating (1=low 6=high) of Social Protection?
Ensure brevity in your answer.  0.21. What is the difference between the highest and the lowest Rating (1=low 6=high) of Quality of public administration?
Keep it short and to the point. 0.15. What is the difference between the highest and the lowest Rating (1=low 6=high) in Public sector management?
Provide a succinct answer. 0.1. 